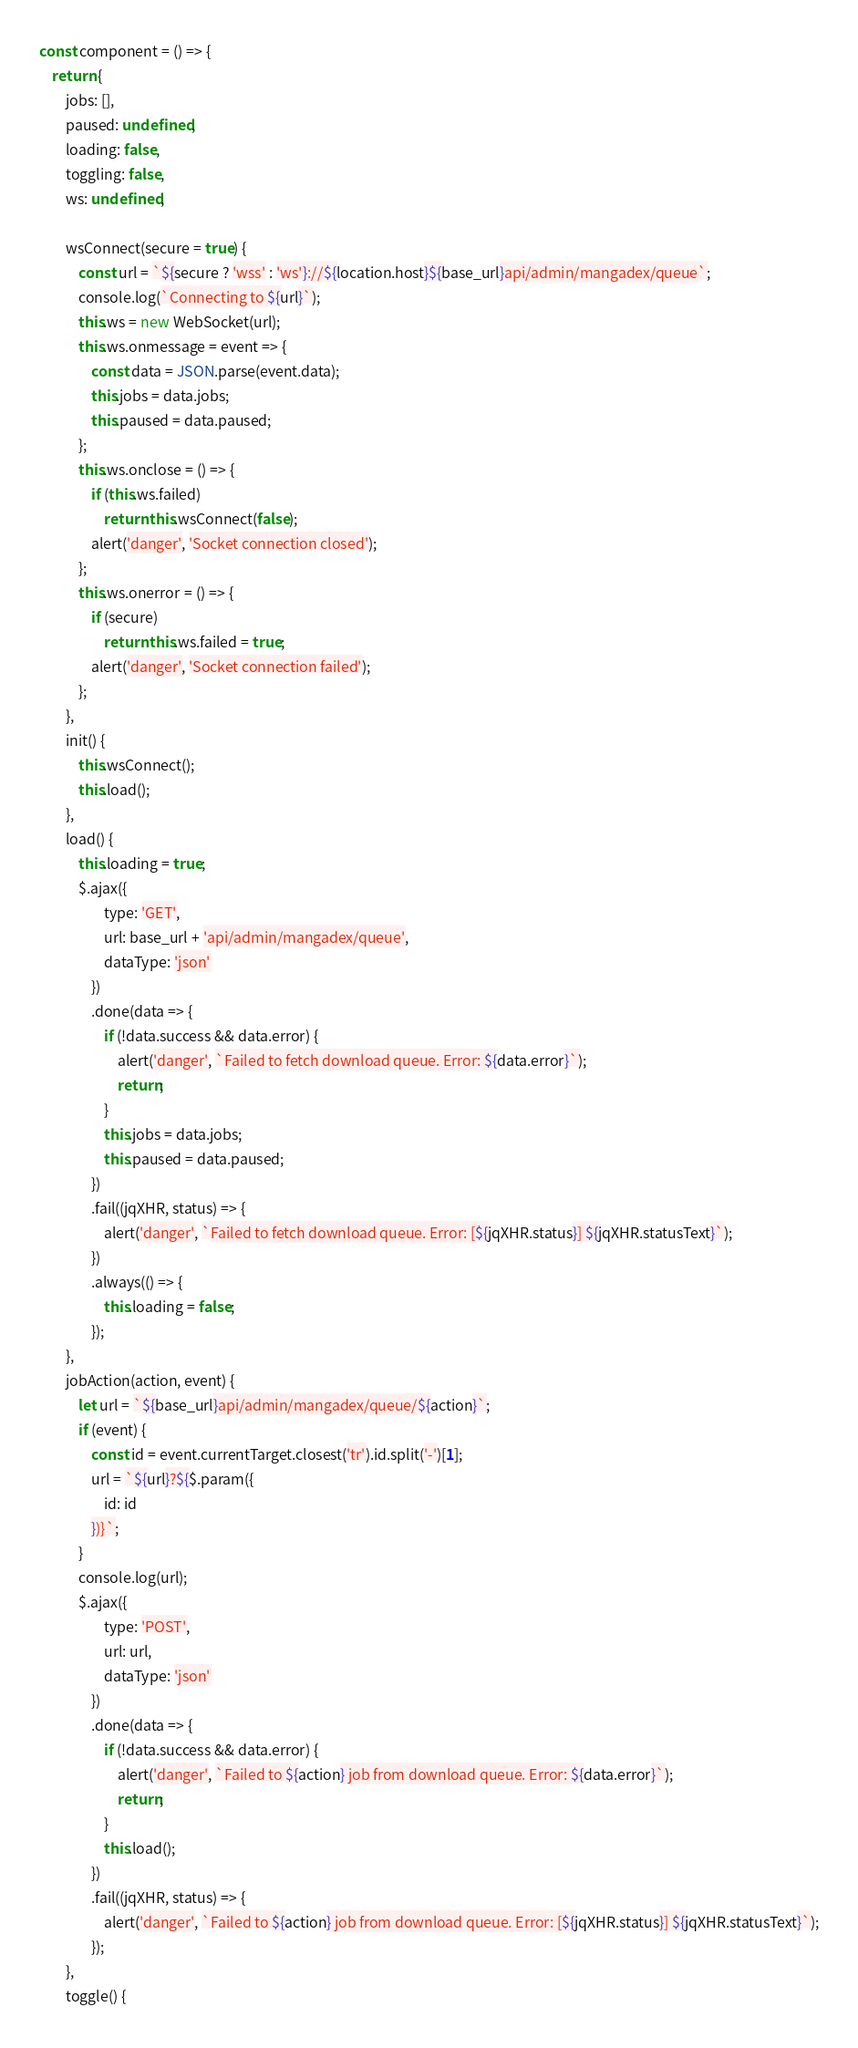Convert code to text. <code><loc_0><loc_0><loc_500><loc_500><_JavaScript_>const component = () => {
	return {
		jobs: [],
		paused: undefined,
		loading: false,
		toggling: false,
		ws: undefined,

		wsConnect(secure = true) {
			const url = `${secure ? 'wss' : 'ws'}://${location.host}${base_url}api/admin/mangadex/queue`;
			console.log(`Connecting to ${url}`);
			this.ws = new WebSocket(url);
			this.ws.onmessage = event => {
				const data = JSON.parse(event.data);
				this.jobs = data.jobs;
				this.paused = data.paused;
			};
			this.ws.onclose = () => {
				if (this.ws.failed)
					return this.wsConnect(false);
				alert('danger', 'Socket connection closed');
			};
			this.ws.onerror = () => {
				if (secure)
					return this.ws.failed = true;
				alert('danger', 'Socket connection failed');
			};
		},
		init() {
			this.wsConnect();
			this.load();
		},
		load() {
			this.loading = true;
			$.ajax({
					type: 'GET',
					url: base_url + 'api/admin/mangadex/queue',
					dataType: 'json'
				})
				.done(data => {
					if (!data.success && data.error) {
						alert('danger', `Failed to fetch download queue. Error: ${data.error}`);
						return;
					}
					this.jobs = data.jobs;
					this.paused = data.paused;
				})
				.fail((jqXHR, status) => {
					alert('danger', `Failed to fetch download queue. Error: [${jqXHR.status}] ${jqXHR.statusText}`);
				})
				.always(() => {
					this.loading = false;
				});
		},
		jobAction(action, event) {
			let url = `${base_url}api/admin/mangadex/queue/${action}`;
			if (event) {
				const id = event.currentTarget.closest('tr').id.split('-')[1];
				url = `${url}?${$.param({
					id: id
				})}`;
			}
			console.log(url);
			$.ajax({
					type: 'POST',
					url: url,
					dataType: 'json'
				})
				.done(data => {
					if (!data.success && data.error) {
						alert('danger', `Failed to ${action} job from download queue. Error: ${data.error}`);
						return;
					}
					this.load();
				})
				.fail((jqXHR, status) => {
					alert('danger', `Failed to ${action} job from download queue. Error: [${jqXHR.status}] ${jqXHR.statusText}`);
				});
		},
		toggle() {</code> 